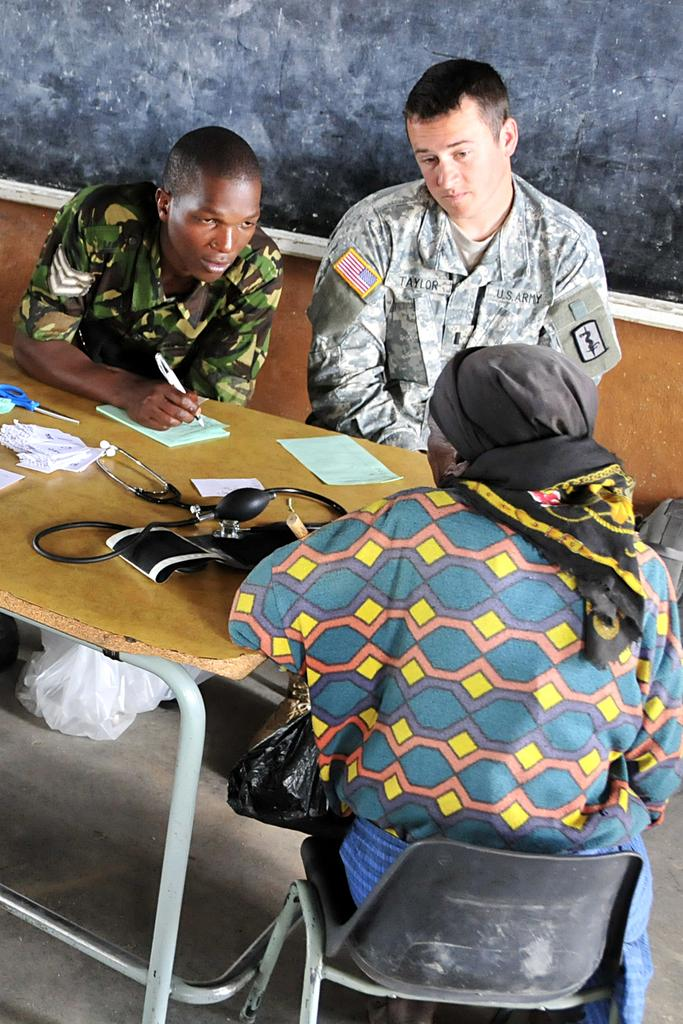What are the people in the image doing? The people in the image are sitting on chairs. What is located in the middle of the image? There is a wooden table in the middle of the image. What can be seen on the table? There are items placed on the table. What is visible in the background of the image? There is a black color board and a wall in the background. How does the duck interact with the people sitting on chairs in the image? There is no duck present in the image; it only features people sitting on chairs, a wooden table, items on the table, and a black color board and wall in the background. 